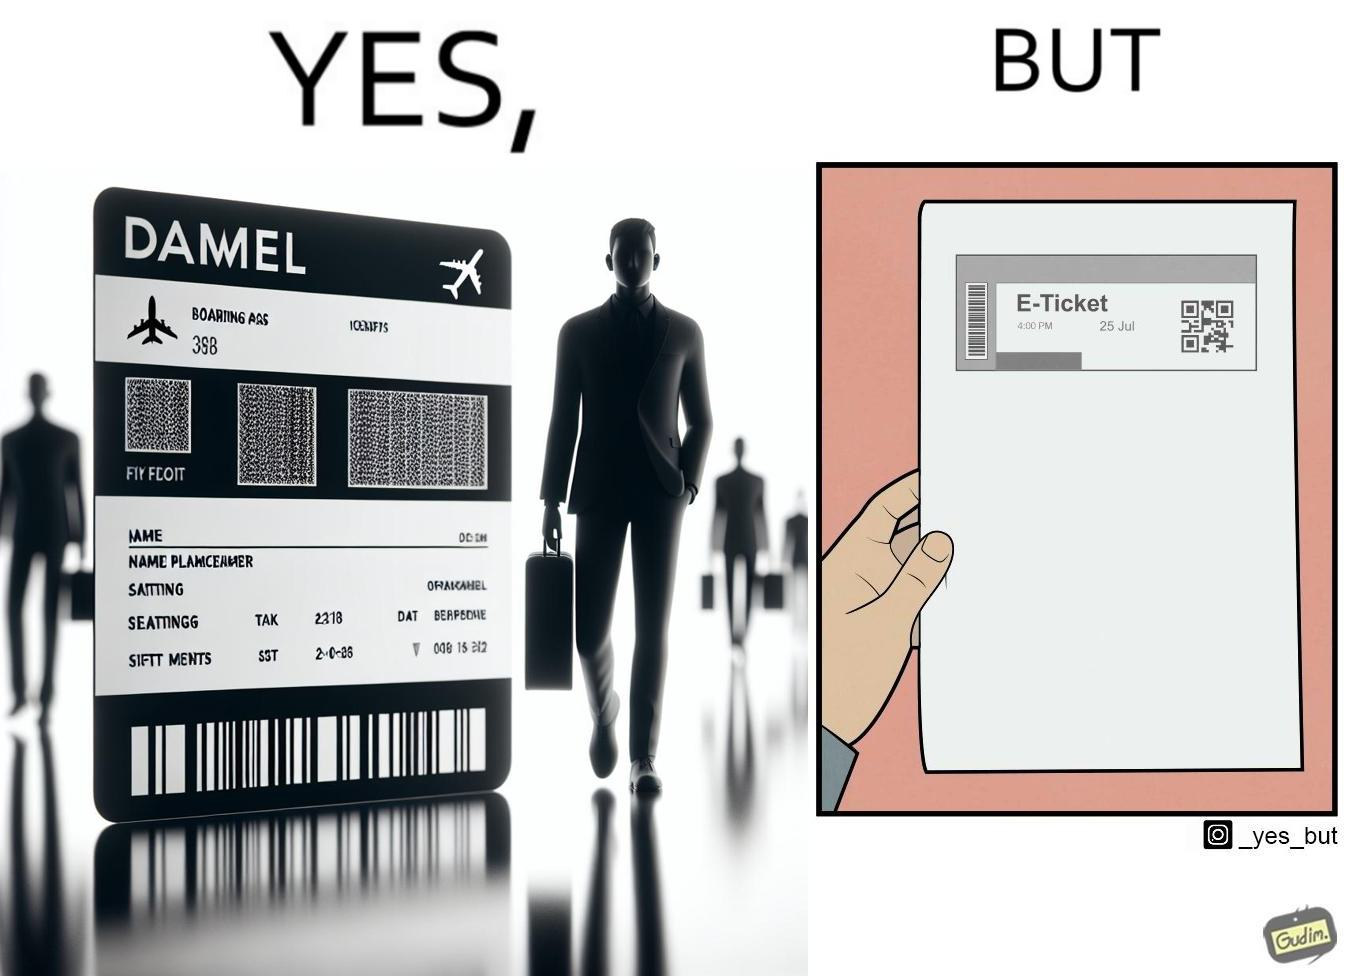Is this a satirical image? Yes, this image is satirical. 